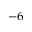<formula> <loc_0><loc_0><loc_500><loc_500>^ { - 6 }</formula> 